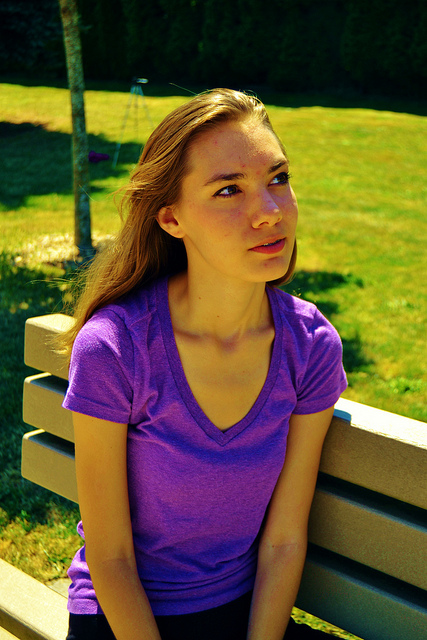<image>What pattern is the girl's shirt? I don't know what pattern the girl's shirt is. It could be solid or plain. What kinds of sounds do these animals make? It is unclear what kinds of sounds these animals make. They might be making many different sounds, including speaking and talking. What pattern is the girl's shirt? It can be seen that the pattern of the girl's shirt is solid. What kinds of sounds do these animals make? I don't know the kinds of sounds these animals make. 